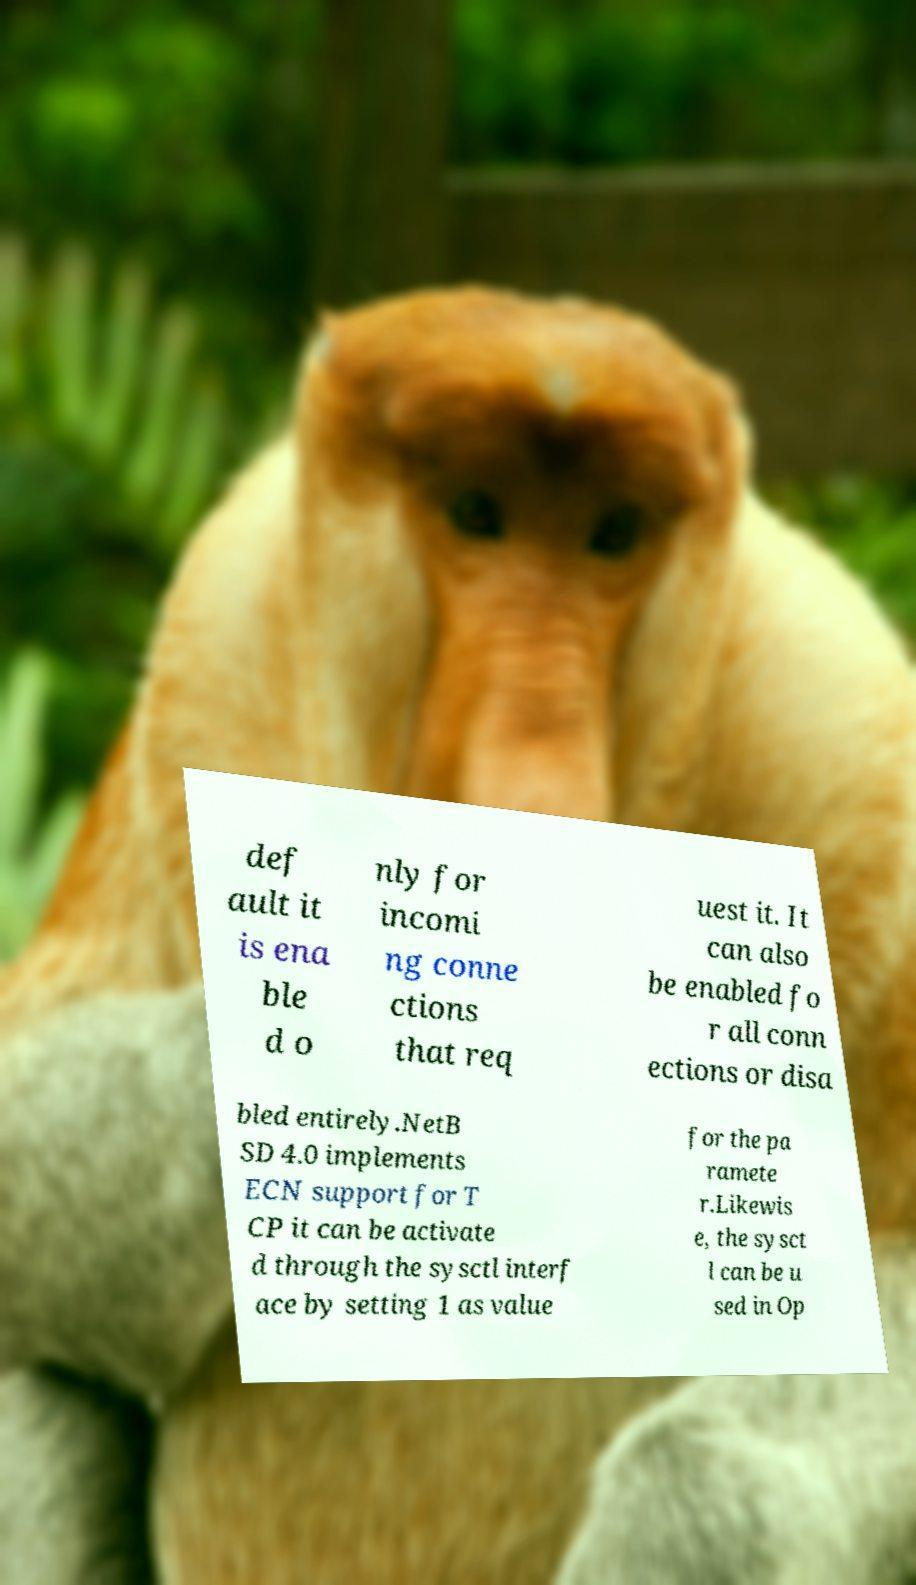Can you read and provide the text displayed in the image?This photo seems to have some interesting text. Can you extract and type it out for me? def ault it is ena ble d o nly for incomi ng conne ctions that req uest it. It can also be enabled fo r all conn ections or disa bled entirely.NetB SD 4.0 implements ECN support for T CP it can be activate d through the sysctl interf ace by setting 1 as value for the pa ramete r.Likewis e, the sysct l can be u sed in Op 